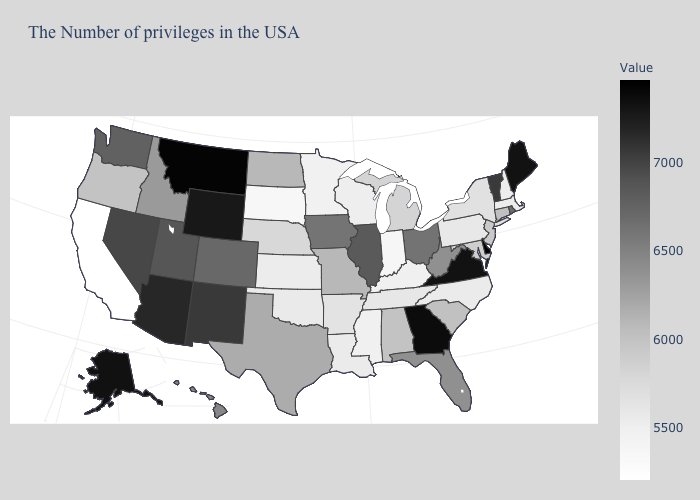Does Alabama have the lowest value in the South?
Be succinct. No. Which states have the lowest value in the USA?
Be succinct. California. 